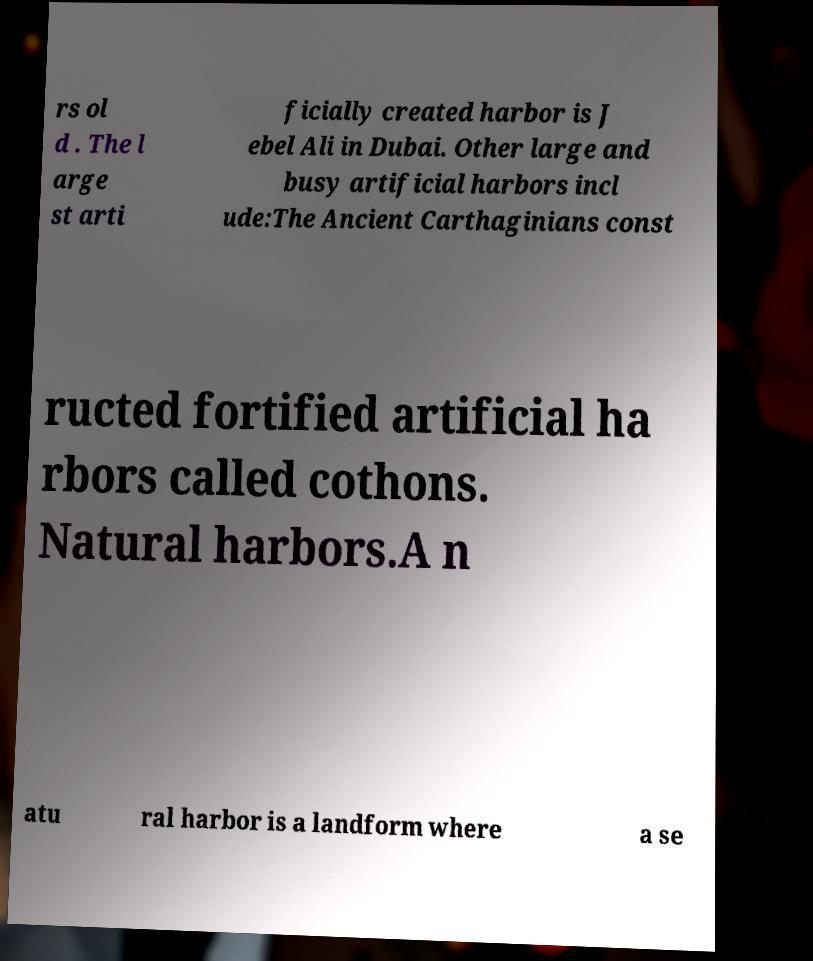For documentation purposes, I need the text within this image transcribed. Could you provide that? rs ol d . The l arge st arti ficially created harbor is J ebel Ali in Dubai. Other large and busy artificial harbors incl ude:The Ancient Carthaginians const ructed fortified artificial ha rbors called cothons. Natural harbors.A n atu ral harbor is a landform where a se 